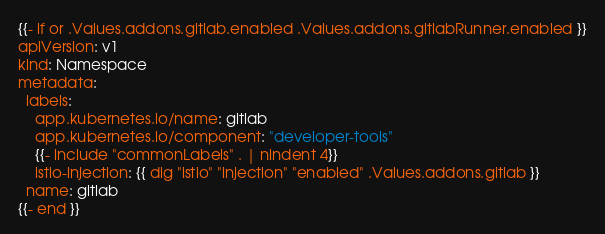Convert code to text. <code><loc_0><loc_0><loc_500><loc_500><_YAML_>{{- if or .Values.addons.gitlab.enabled .Values.addons.gitlabRunner.enabled }}
apiVersion: v1
kind: Namespace
metadata:
  labels:
    app.kubernetes.io/name: gitlab
    app.kubernetes.io/component: "developer-tools"
    {{- include "commonLabels" . | nindent 4}}
    istio-injection: {{ dig "istio" "injection" "enabled" .Values.addons.gitlab }}
  name: gitlab
{{- end }}
</code> 